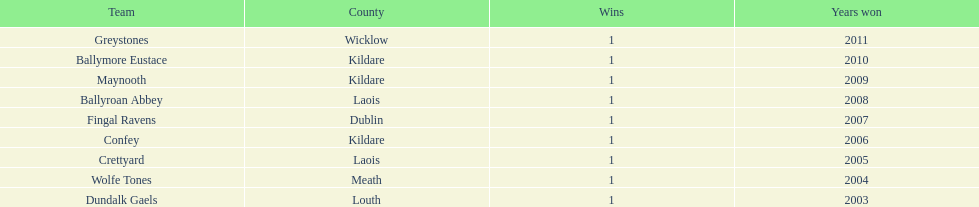Which county had the highest number of victories? Kildare. 